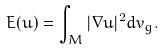<formula> <loc_0><loc_0><loc_500><loc_500>E ( u ) = \int _ { M } | \nabla u | ^ { 2 } d v _ { g } .</formula> 